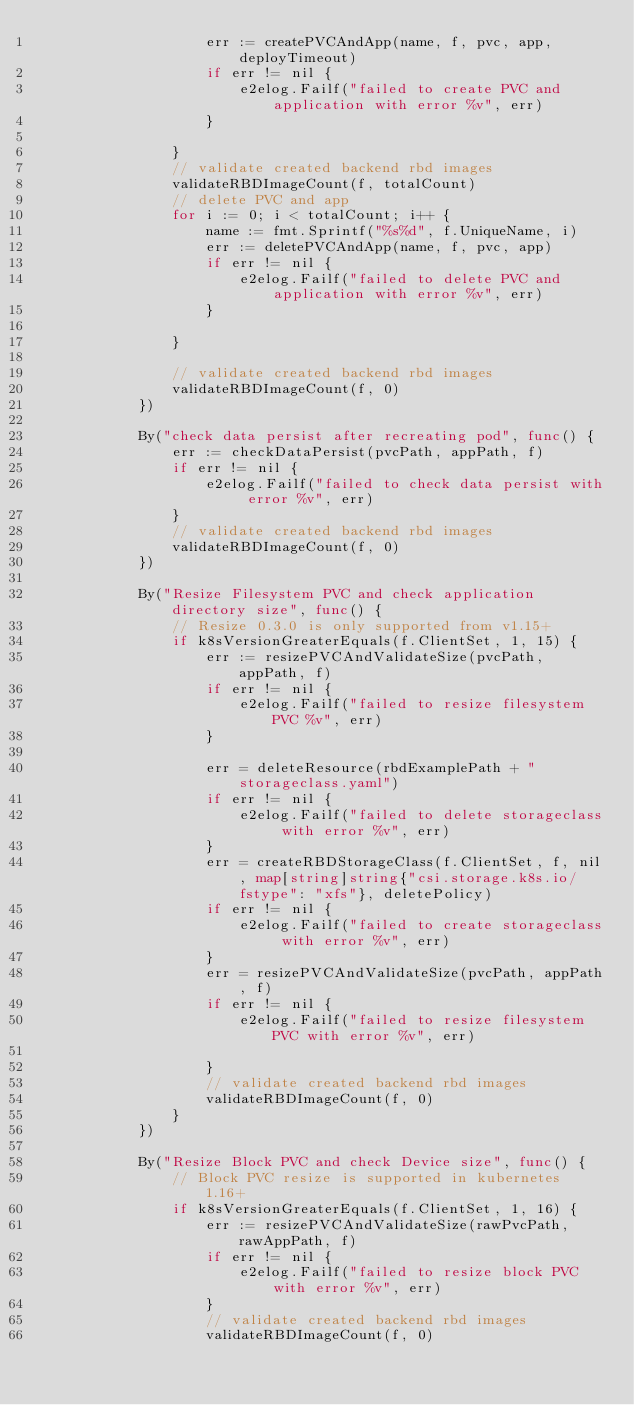Convert code to text. <code><loc_0><loc_0><loc_500><loc_500><_Go_>					err := createPVCAndApp(name, f, pvc, app, deployTimeout)
					if err != nil {
						e2elog.Failf("failed to create PVC and application with error %v", err)
					}

				}
				// validate created backend rbd images
				validateRBDImageCount(f, totalCount)
				// delete PVC and app
				for i := 0; i < totalCount; i++ {
					name := fmt.Sprintf("%s%d", f.UniqueName, i)
					err := deletePVCAndApp(name, f, pvc, app)
					if err != nil {
						e2elog.Failf("failed to delete PVC and application with error %v", err)
					}

				}

				// validate created backend rbd images
				validateRBDImageCount(f, 0)
			})

			By("check data persist after recreating pod", func() {
				err := checkDataPersist(pvcPath, appPath, f)
				if err != nil {
					e2elog.Failf("failed to check data persist with error %v", err)
				}
				// validate created backend rbd images
				validateRBDImageCount(f, 0)
			})

			By("Resize Filesystem PVC and check application directory size", func() {
				// Resize 0.3.0 is only supported from v1.15+
				if k8sVersionGreaterEquals(f.ClientSet, 1, 15) {
					err := resizePVCAndValidateSize(pvcPath, appPath, f)
					if err != nil {
						e2elog.Failf("failed to resize filesystem PVC %v", err)
					}

					err = deleteResource(rbdExamplePath + "storageclass.yaml")
					if err != nil {
						e2elog.Failf("failed to delete storageclass with error %v", err)
					}
					err = createRBDStorageClass(f.ClientSet, f, nil, map[string]string{"csi.storage.k8s.io/fstype": "xfs"}, deletePolicy)
					if err != nil {
						e2elog.Failf("failed to create storageclass with error %v", err)
					}
					err = resizePVCAndValidateSize(pvcPath, appPath, f)
					if err != nil {
						e2elog.Failf("failed to resize filesystem PVC with error %v", err)

					}
					// validate created backend rbd images
					validateRBDImageCount(f, 0)
				}
			})

			By("Resize Block PVC and check Device size", func() {
				// Block PVC resize is supported in kubernetes 1.16+
				if k8sVersionGreaterEquals(f.ClientSet, 1, 16) {
					err := resizePVCAndValidateSize(rawPvcPath, rawAppPath, f)
					if err != nil {
						e2elog.Failf("failed to resize block PVC with error %v", err)
					}
					// validate created backend rbd images
					validateRBDImageCount(f, 0)</code> 